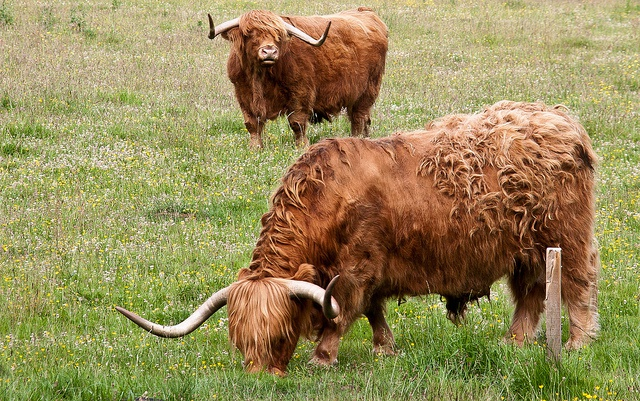Describe the objects in this image and their specific colors. I can see cow in tan, maroon, brown, black, and salmon tones and cow in tan, maroon, brown, and black tones in this image. 